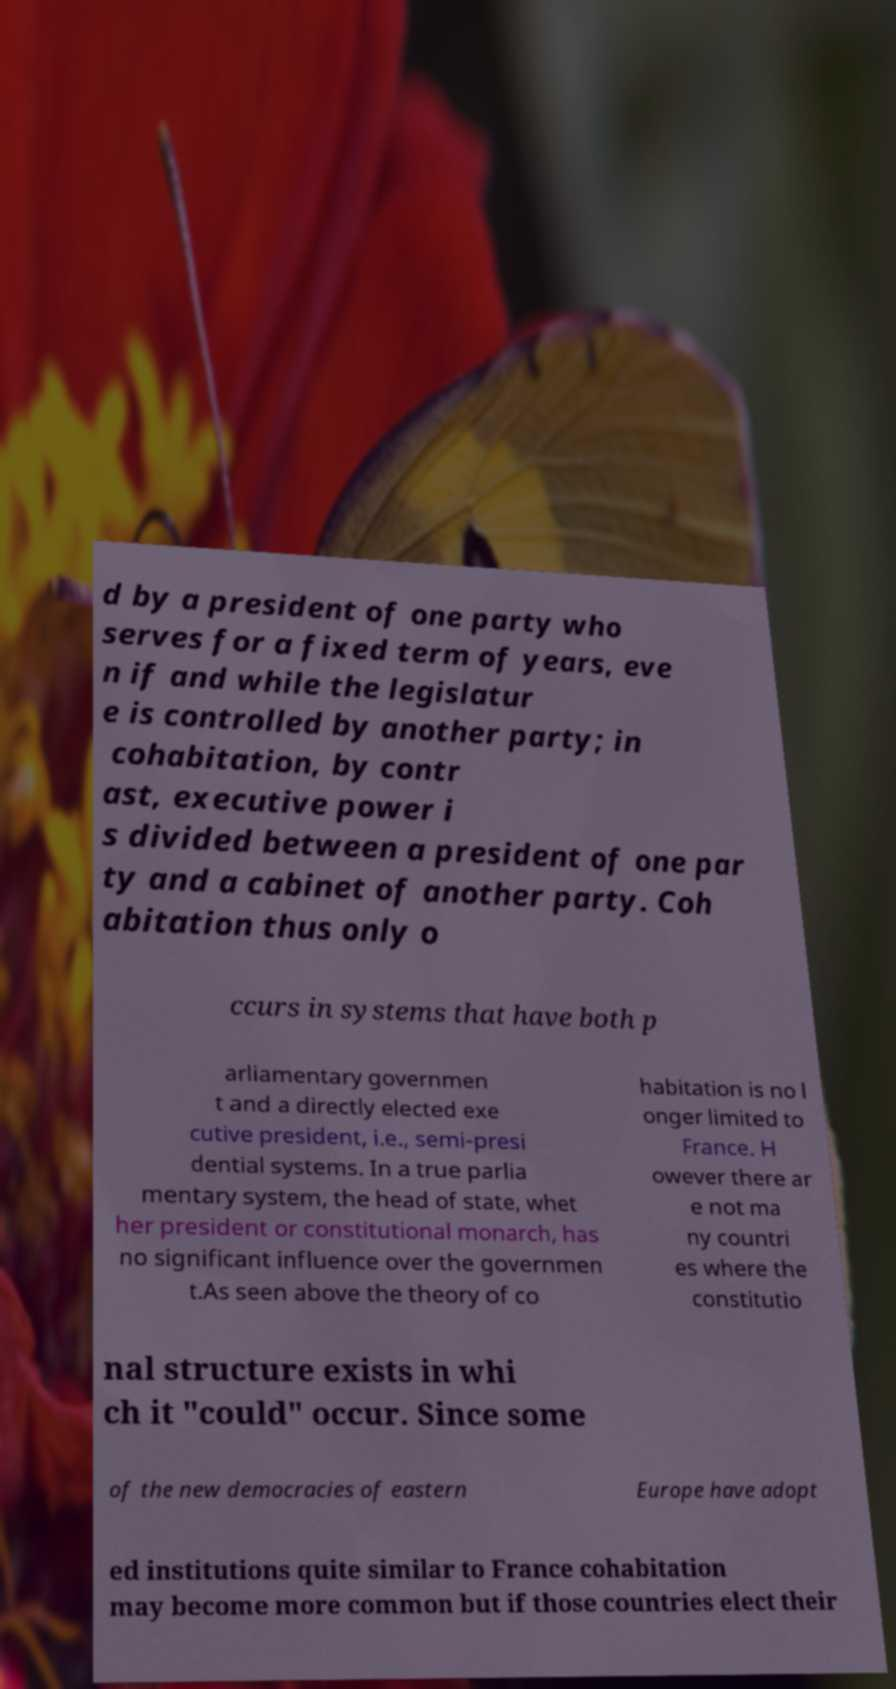I need the written content from this picture converted into text. Can you do that? d by a president of one party who serves for a fixed term of years, eve n if and while the legislatur e is controlled by another party; in cohabitation, by contr ast, executive power i s divided between a president of one par ty and a cabinet of another party. Coh abitation thus only o ccurs in systems that have both p arliamentary governmen t and a directly elected exe cutive president, i.e., semi-presi dential systems. In a true parlia mentary system, the head of state, whet her president or constitutional monarch, has no significant influence over the governmen t.As seen above the theory of co habitation is no l onger limited to France. H owever there ar e not ma ny countri es where the constitutio nal structure exists in whi ch it "could" occur. Since some of the new democracies of eastern Europe have adopt ed institutions quite similar to France cohabitation may become more common but if those countries elect their 